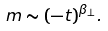Convert formula to latex. <formula><loc_0><loc_0><loc_500><loc_500>m \sim ( - t ) ^ { \beta _ { \bot } } .</formula> 